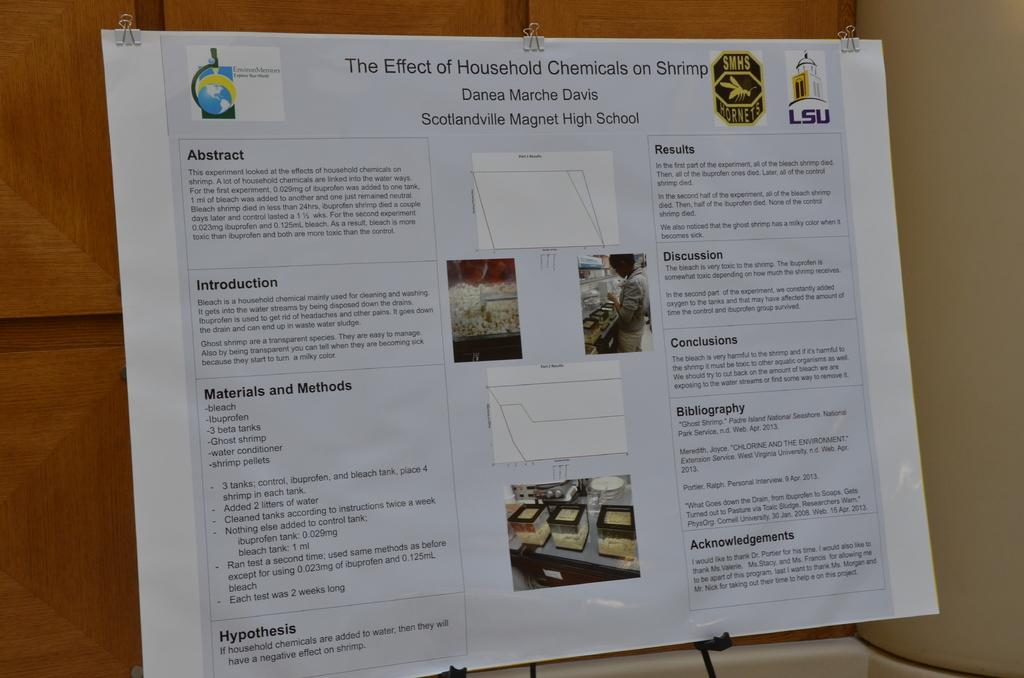<image>
Write a terse but informative summary of the picture. A display of the Effects of Household Chemicals on Shrimp. 